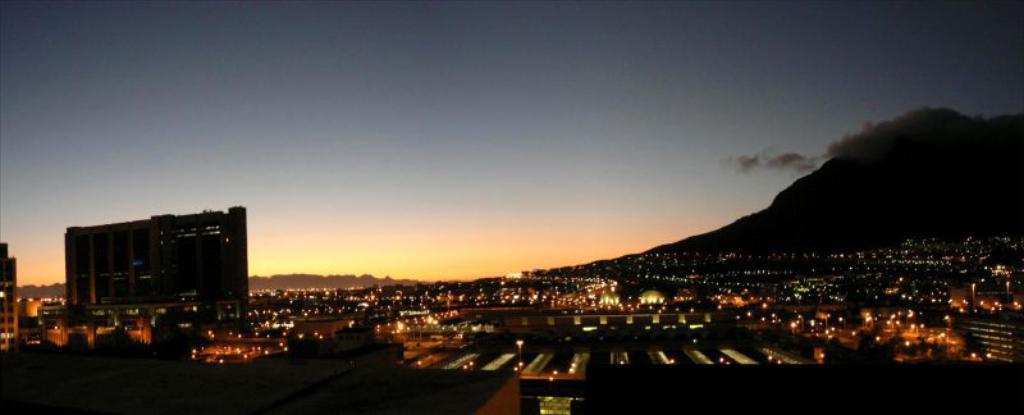Could you give a brief overview of what you see in this image? In this image I can see houses, trees, buildings, street lights and lights. In the background I can see a mountain, smoke and the sky. This image is taken during night. 